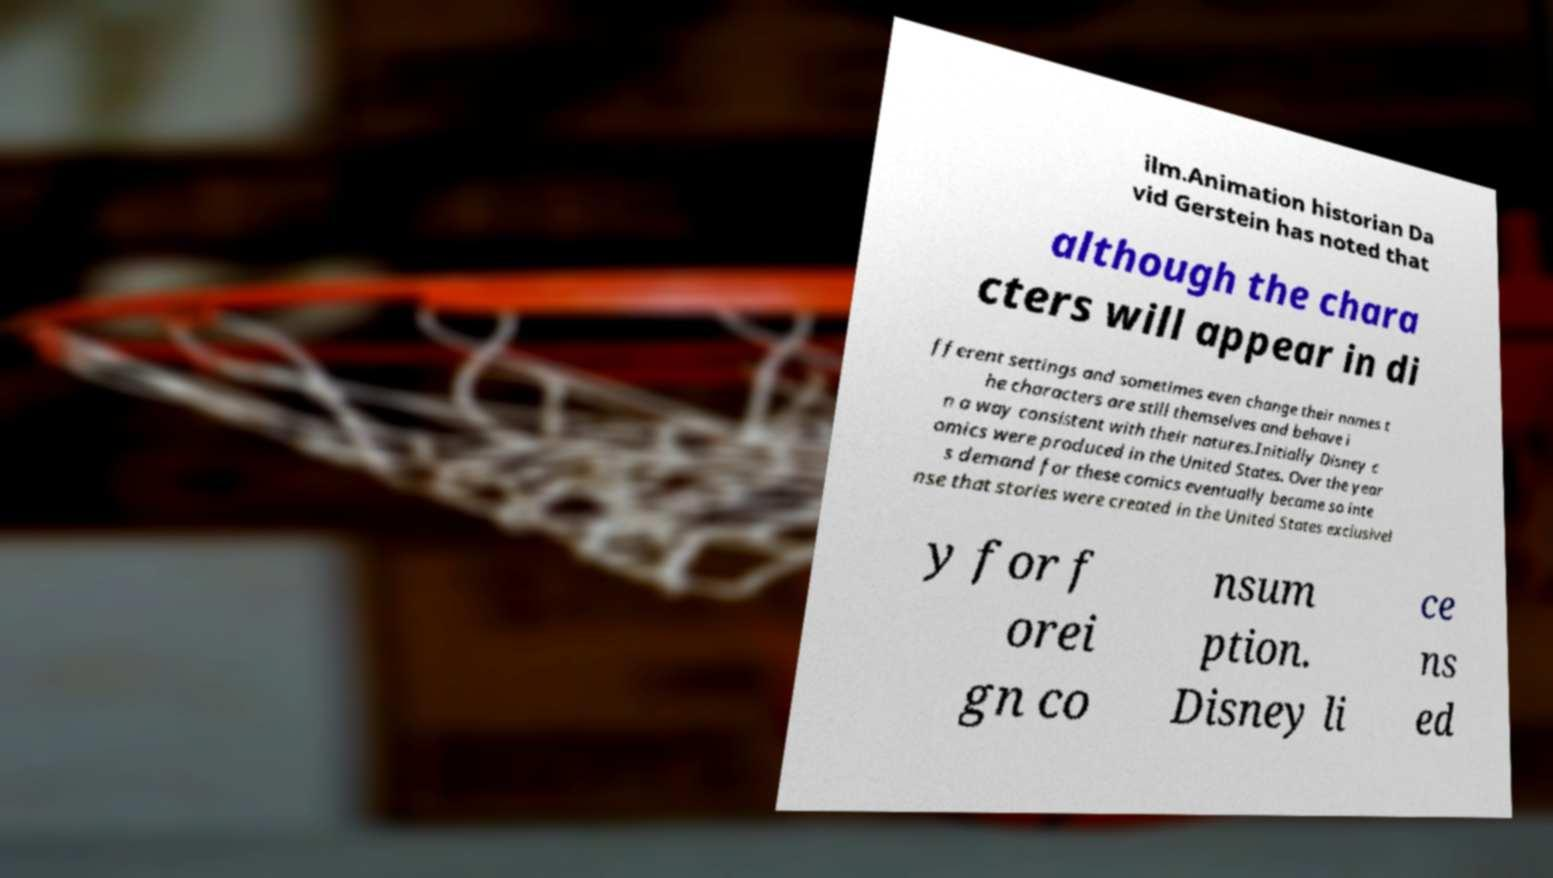Can you accurately transcribe the text from the provided image for me? ilm.Animation historian Da vid Gerstein has noted that although the chara cters will appear in di fferent settings and sometimes even change their names t he characters are still themselves and behave i n a way consistent with their natures.Initially Disney c omics were produced in the United States. Over the year s demand for these comics eventually became so inte nse that stories were created in the United States exclusivel y for f orei gn co nsum ption. Disney li ce ns ed 